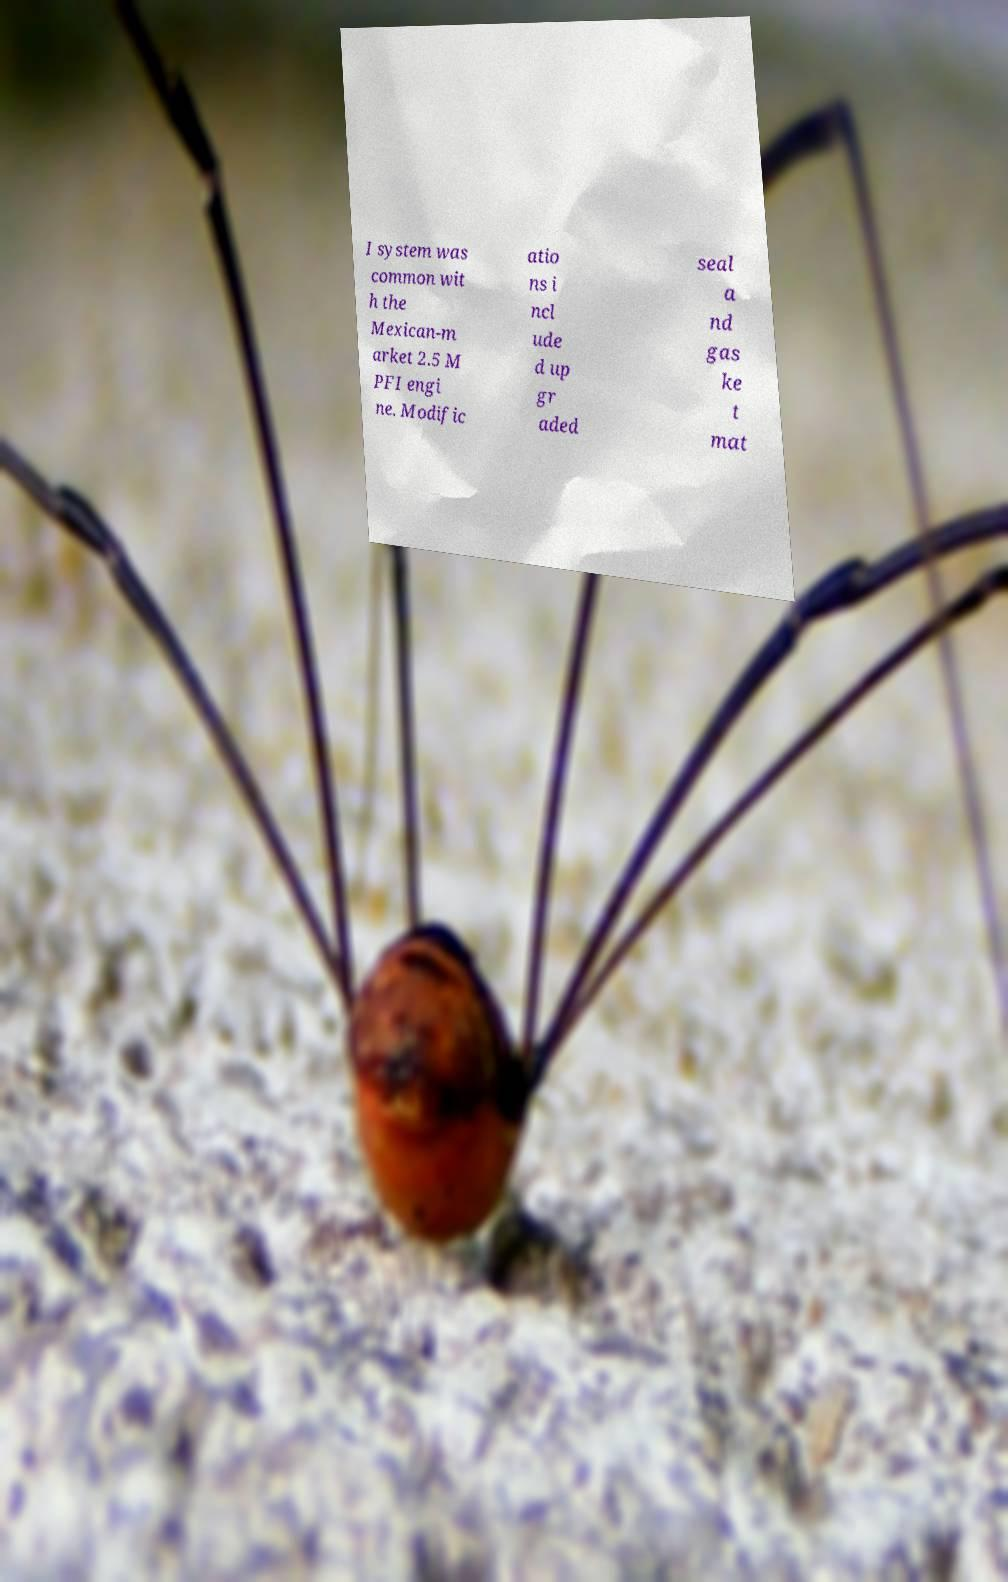Can you accurately transcribe the text from the provided image for me? I system was common wit h the Mexican-m arket 2.5 M PFI engi ne. Modific atio ns i ncl ude d up gr aded seal a nd gas ke t mat 